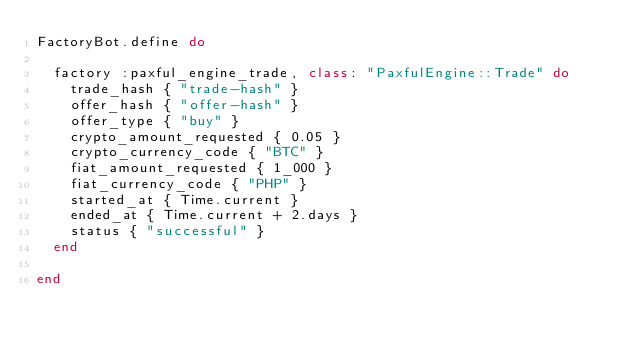Convert code to text. <code><loc_0><loc_0><loc_500><loc_500><_Ruby_>FactoryBot.define do

  factory :paxful_engine_trade, class: "PaxfulEngine::Trade" do
    trade_hash { "trade-hash" }
    offer_hash { "offer-hash" }
    offer_type { "buy" }
    crypto_amount_requested { 0.05 }
    crypto_currency_code { "BTC" }
    fiat_amount_requested { 1_000 }
    fiat_currency_code { "PHP" }
    started_at { Time.current }
    ended_at { Time.current + 2.days }
    status { "successful" }
  end

end
</code> 